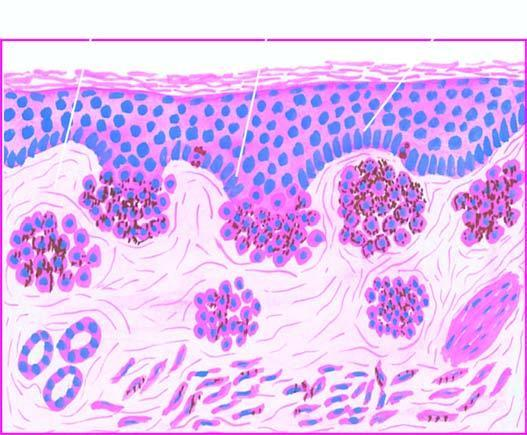what do these cells contain?
Answer the question using a single word or phrase. Coarse 